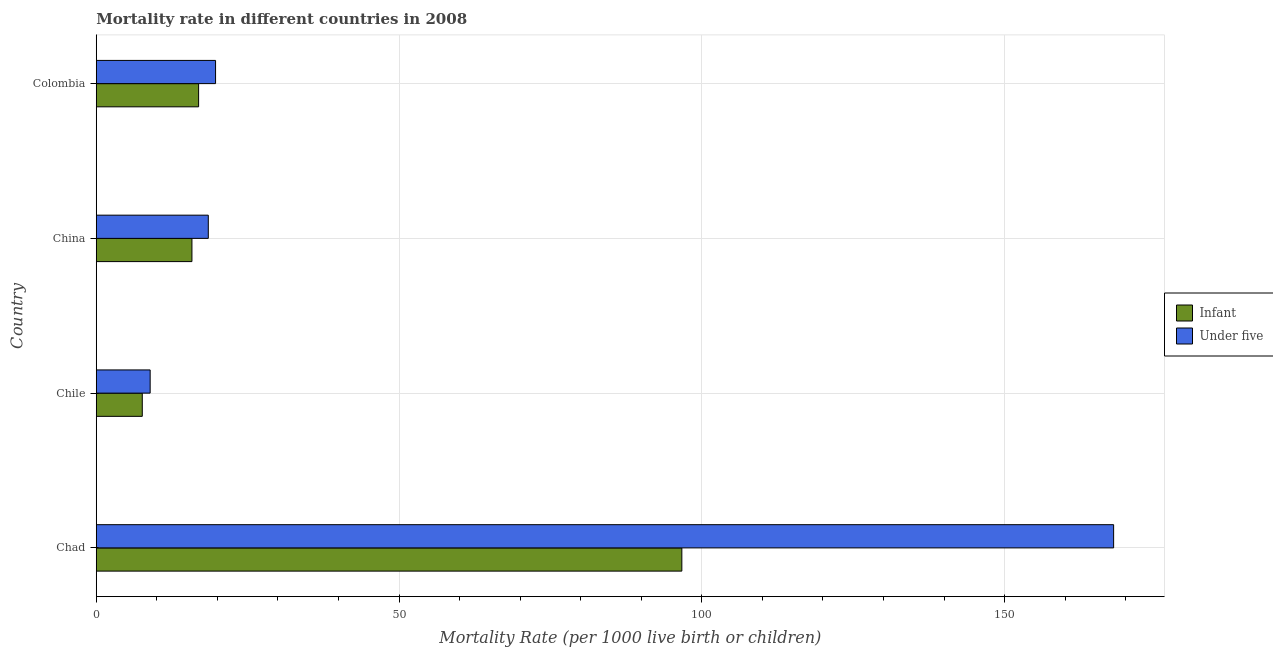How many different coloured bars are there?
Ensure brevity in your answer.  2. Are the number of bars on each tick of the Y-axis equal?
Your answer should be very brief. Yes. How many bars are there on the 2nd tick from the top?
Make the answer very short. 2. How many bars are there on the 1st tick from the bottom?
Offer a terse response. 2. What is the label of the 2nd group of bars from the top?
Make the answer very short. China. Across all countries, what is the maximum under-5 mortality rate?
Your answer should be compact. 168. Across all countries, what is the minimum under-5 mortality rate?
Ensure brevity in your answer.  8.9. In which country was the under-5 mortality rate maximum?
Ensure brevity in your answer.  Chad. In which country was the infant mortality rate minimum?
Your answer should be compact. Chile. What is the total under-5 mortality rate in the graph?
Your answer should be compact. 215.1. What is the difference between the under-5 mortality rate in China and the infant mortality rate in Chile?
Ensure brevity in your answer.  10.9. What is the average infant mortality rate per country?
Make the answer very short. 34.25. What is the difference between the infant mortality rate and under-5 mortality rate in China?
Your response must be concise. -2.7. What is the ratio of the infant mortality rate in Chad to that in Colombia?
Offer a terse response. 5.72. Is the difference between the under-5 mortality rate in Chile and Colombia greater than the difference between the infant mortality rate in Chile and Colombia?
Offer a very short reply. No. What is the difference between the highest and the second highest infant mortality rate?
Provide a short and direct response. 79.8. What is the difference between the highest and the lowest under-5 mortality rate?
Provide a succinct answer. 159.1. In how many countries, is the under-5 mortality rate greater than the average under-5 mortality rate taken over all countries?
Provide a succinct answer. 1. What does the 2nd bar from the top in Chad represents?
Give a very brief answer. Infant. What does the 1st bar from the bottom in Chile represents?
Provide a short and direct response. Infant. Are all the bars in the graph horizontal?
Provide a short and direct response. Yes. How many countries are there in the graph?
Ensure brevity in your answer.  4. Where does the legend appear in the graph?
Offer a terse response. Center right. How are the legend labels stacked?
Provide a short and direct response. Vertical. What is the title of the graph?
Offer a terse response. Mortality rate in different countries in 2008. What is the label or title of the X-axis?
Offer a terse response. Mortality Rate (per 1000 live birth or children). What is the label or title of the Y-axis?
Provide a short and direct response. Country. What is the Mortality Rate (per 1000 live birth or children) in Infant in Chad?
Give a very brief answer. 96.7. What is the Mortality Rate (per 1000 live birth or children) in Under five in Chad?
Ensure brevity in your answer.  168. What is the Mortality Rate (per 1000 live birth or children) in Infant in Chile?
Offer a terse response. 7.6. What is the Mortality Rate (per 1000 live birth or children) of Under five in Chile?
Your response must be concise. 8.9. What is the Mortality Rate (per 1000 live birth or children) of Infant in China?
Make the answer very short. 15.8. What is the Mortality Rate (per 1000 live birth or children) in Under five in Colombia?
Provide a succinct answer. 19.7. Across all countries, what is the maximum Mortality Rate (per 1000 live birth or children) of Infant?
Give a very brief answer. 96.7. Across all countries, what is the maximum Mortality Rate (per 1000 live birth or children) of Under five?
Your answer should be compact. 168. What is the total Mortality Rate (per 1000 live birth or children) of Infant in the graph?
Offer a very short reply. 137. What is the total Mortality Rate (per 1000 live birth or children) in Under five in the graph?
Your response must be concise. 215.1. What is the difference between the Mortality Rate (per 1000 live birth or children) of Infant in Chad and that in Chile?
Give a very brief answer. 89.1. What is the difference between the Mortality Rate (per 1000 live birth or children) in Under five in Chad and that in Chile?
Your answer should be very brief. 159.1. What is the difference between the Mortality Rate (per 1000 live birth or children) in Infant in Chad and that in China?
Give a very brief answer. 80.9. What is the difference between the Mortality Rate (per 1000 live birth or children) of Under five in Chad and that in China?
Your answer should be very brief. 149.5. What is the difference between the Mortality Rate (per 1000 live birth or children) in Infant in Chad and that in Colombia?
Your answer should be very brief. 79.8. What is the difference between the Mortality Rate (per 1000 live birth or children) in Under five in Chad and that in Colombia?
Your answer should be compact. 148.3. What is the difference between the Mortality Rate (per 1000 live birth or children) of Infant in Chile and that in China?
Ensure brevity in your answer.  -8.2. What is the difference between the Mortality Rate (per 1000 live birth or children) of Infant in Chile and that in Colombia?
Ensure brevity in your answer.  -9.3. What is the difference between the Mortality Rate (per 1000 live birth or children) of Under five in Chile and that in Colombia?
Offer a very short reply. -10.8. What is the difference between the Mortality Rate (per 1000 live birth or children) in Infant in Chad and the Mortality Rate (per 1000 live birth or children) in Under five in Chile?
Your answer should be very brief. 87.8. What is the difference between the Mortality Rate (per 1000 live birth or children) of Infant in Chad and the Mortality Rate (per 1000 live birth or children) of Under five in China?
Provide a short and direct response. 78.2. What is the difference between the Mortality Rate (per 1000 live birth or children) of Infant in Chile and the Mortality Rate (per 1000 live birth or children) of Under five in Colombia?
Provide a succinct answer. -12.1. What is the difference between the Mortality Rate (per 1000 live birth or children) of Infant in China and the Mortality Rate (per 1000 live birth or children) of Under five in Colombia?
Provide a succinct answer. -3.9. What is the average Mortality Rate (per 1000 live birth or children) in Infant per country?
Make the answer very short. 34.25. What is the average Mortality Rate (per 1000 live birth or children) of Under five per country?
Provide a succinct answer. 53.77. What is the difference between the Mortality Rate (per 1000 live birth or children) in Infant and Mortality Rate (per 1000 live birth or children) in Under five in Chad?
Your answer should be compact. -71.3. What is the ratio of the Mortality Rate (per 1000 live birth or children) in Infant in Chad to that in Chile?
Provide a succinct answer. 12.72. What is the ratio of the Mortality Rate (per 1000 live birth or children) in Under five in Chad to that in Chile?
Give a very brief answer. 18.88. What is the ratio of the Mortality Rate (per 1000 live birth or children) in Infant in Chad to that in China?
Keep it short and to the point. 6.12. What is the ratio of the Mortality Rate (per 1000 live birth or children) of Under five in Chad to that in China?
Your answer should be very brief. 9.08. What is the ratio of the Mortality Rate (per 1000 live birth or children) of Infant in Chad to that in Colombia?
Make the answer very short. 5.72. What is the ratio of the Mortality Rate (per 1000 live birth or children) of Under five in Chad to that in Colombia?
Provide a succinct answer. 8.53. What is the ratio of the Mortality Rate (per 1000 live birth or children) of Infant in Chile to that in China?
Your answer should be compact. 0.48. What is the ratio of the Mortality Rate (per 1000 live birth or children) of Under five in Chile to that in China?
Ensure brevity in your answer.  0.48. What is the ratio of the Mortality Rate (per 1000 live birth or children) in Infant in Chile to that in Colombia?
Your response must be concise. 0.45. What is the ratio of the Mortality Rate (per 1000 live birth or children) of Under five in Chile to that in Colombia?
Make the answer very short. 0.45. What is the ratio of the Mortality Rate (per 1000 live birth or children) of Infant in China to that in Colombia?
Provide a succinct answer. 0.93. What is the ratio of the Mortality Rate (per 1000 live birth or children) in Under five in China to that in Colombia?
Your response must be concise. 0.94. What is the difference between the highest and the second highest Mortality Rate (per 1000 live birth or children) of Infant?
Offer a very short reply. 79.8. What is the difference between the highest and the second highest Mortality Rate (per 1000 live birth or children) of Under five?
Give a very brief answer. 148.3. What is the difference between the highest and the lowest Mortality Rate (per 1000 live birth or children) of Infant?
Your answer should be very brief. 89.1. What is the difference between the highest and the lowest Mortality Rate (per 1000 live birth or children) in Under five?
Your response must be concise. 159.1. 